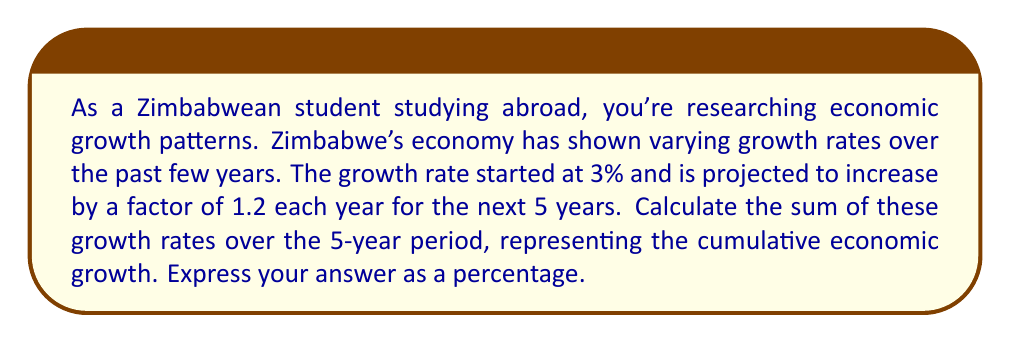Help me with this question. Let's approach this step-by-step using the formula for the sum of a geometric series:

1) First, identify the components of our geometric series:
   - First term, $a = 3\%$ (or 0.03 in decimal form)
   - Common ratio, $r = 1.2$
   - Number of terms, $n = 5$

2) The formula for the sum of a geometric series is:

   $$S_n = \frac{a(1-r^n)}{1-r}$$

   Where $S_n$ is the sum of the series, $a$ is the first term, $r$ is the common ratio, and $n$ is the number of terms.

3) Substituting our values:

   $$S_5 = \frac{0.03(1-1.2^5)}{1-1.2}$$

4) Calculate $1.2^5$:
   
   $$1.2^5 = 2.4883$$

5) Substitute this value:

   $$S_5 = \frac{0.03(1-2.4883)}{1-1.2} = \frac{0.03(-1.4883)}{-0.2}$$

6) Simplify:

   $$S_5 = \frac{-0.044649}{-0.2} = 0.2232445$$

7) Convert to a percentage:

   $$0.2232445 * 100\% = 22.32445\%$$

Therefore, the sum of the growth rates over the 5-year period is approximately 22.32%.
Answer: 22.32% 